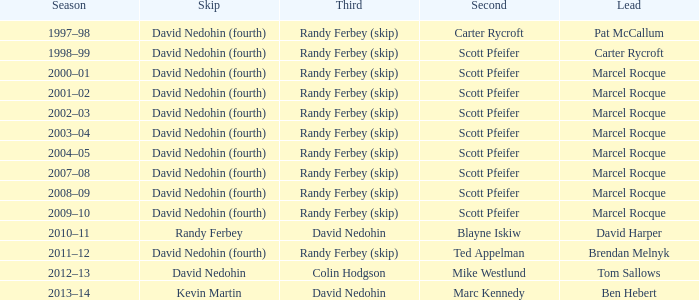Which Second has a Third of david nedohin, and a Lead of ben hebert? Marc Kennedy. 